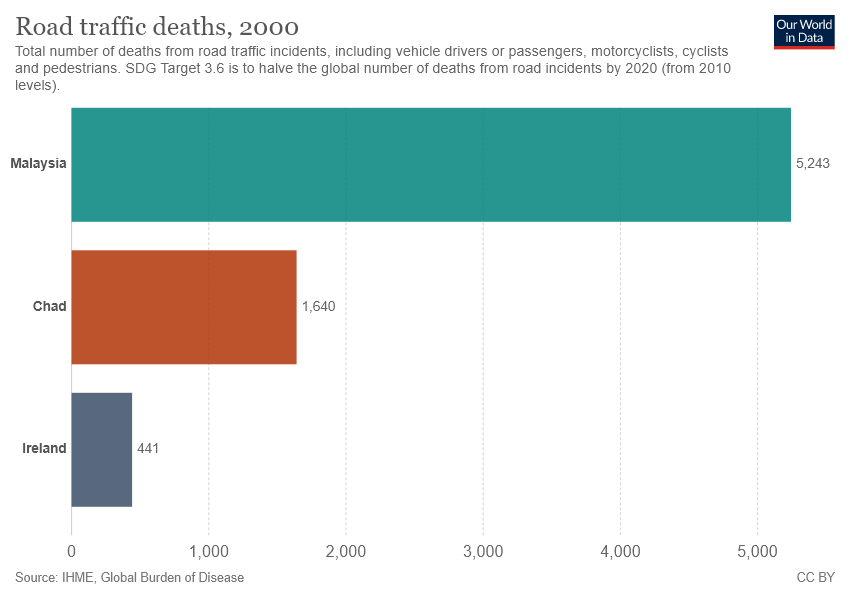Mention a couple of crucial points in this snapshot. The sum of the smallest two bars is not half the value of the largest bar. The value of the largest bar is 5243. 